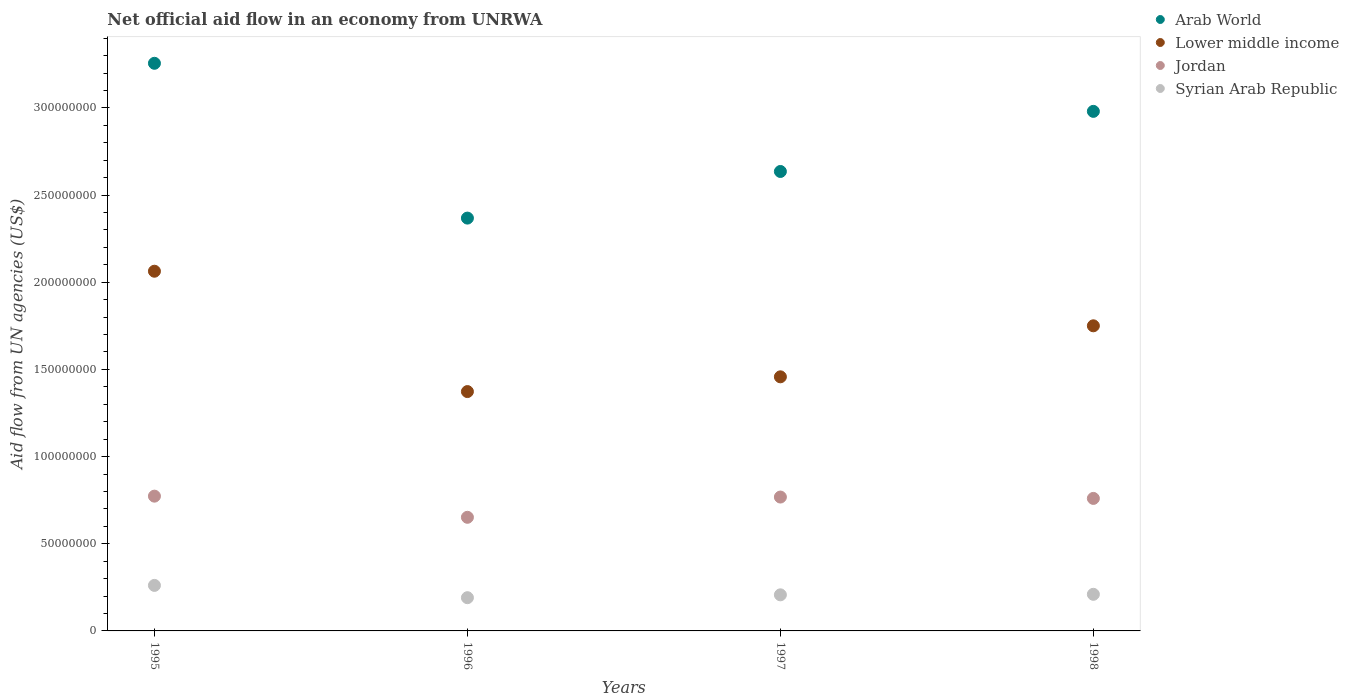How many different coloured dotlines are there?
Provide a succinct answer. 4. Is the number of dotlines equal to the number of legend labels?
Your answer should be very brief. Yes. What is the net official aid flow in Syrian Arab Republic in 1997?
Provide a succinct answer. 2.07e+07. Across all years, what is the maximum net official aid flow in Lower middle income?
Provide a short and direct response. 2.06e+08. Across all years, what is the minimum net official aid flow in Arab World?
Provide a short and direct response. 2.37e+08. In which year was the net official aid flow in Syrian Arab Republic maximum?
Make the answer very short. 1995. What is the total net official aid flow in Lower middle income in the graph?
Keep it short and to the point. 6.64e+08. What is the difference between the net official aid flow in Syrian Arab Republic in 1996 and that in 1998?
Keep it short and to the point. -1.94e+06. What is the difference between the net official aid flow in Arab World in 1995 and the net official aid flow in Jordan in 1997?
Offer a very short reply. 2.49e+08. What is the average net official aid flow in Lower middle income per year?
Make the answer very short. 1.66e+08. In the year 1995, what is the difference between the net official aid flow in Arab World and net official aid flow in Jordan?
Offer a very short reply. 2.48e+08. In how many years, is the net official aid flow in Lower middle income greater than 290000000 US$?
Your response must be concise. 0. What is the ratio of the net official aid flow in Arab World in 1996 to that in 1997?
Keep it short and to the point. 0.9. Is the net official aid flow in Lower middle income in 1996 less than that in 1998?
Provide a succinct answer. Yes. What is the difference between the highest and the second highest net official aid flow in Jordan?
Your answer should be compact. 5.20e+05. What is the difference between the highest and the lowest net official aid flow in Lower middle income?
Offer a terse response. 6.90e+07. Is it the case that in every year, the sum of the net official aid flow in Arab World and net official aid flow in Jordan  is greater than the sum of net official aid flow in Lower middle income and net official aid flow in Syrian Arab Republic?
Offer a very short reply. Yes. Does the net official aid flow in Lower middle income monotonically increase over the years?
Your answer should be very brief. No. Is the net official aid flow in Syrian Arab Republic strictly greater than the net official aid flow in Arab World over the years?
Provide a short and direct response. No. Does the graph contain grids?
Make the answer very short. No. How many legend labels are there?
Give a very brief answer. 4. What is the title of the graph?
Offer a very short reply. Net official aid flow in an economy from UNRWA. What is the label or title of the Y-axis?
Keep it short and to the point. Aid flow from UN agencies (US$). What is the Aid flow from UN agencies (US$) in Arab World in 1995?
Your response must be concise. 3.26e+08. What is the Aid flow from UN agencies (US$) of Lower middle income in 1995?
Keep it short and to the point. 2.06e+08. What is the Aid flow from UN agencies (US$) in Jordan in 1995?
Provide a succinct answer. 7.73e+07. What is the Aid flow from UN agencies (US$) of Syrian Arab Republic in 1995?
Make the answer very short. 2.61e+07. What is the Aid flow from UN agencies (US$) of Arab World in 1996?
Keep it short and to the point. 2.37e+08. What is the Aid flow from UN agencies (US$) of Lower middle income in 1996?
Provide a short and direct response. 1.37e+08. What is the Aid flow from UN agencies (US$) of Jordan in 1996?
Your answer should be very brief. 6.52e+07. What is the Aid flow from UN agencies (US$) in Syrian Arab Republic in 1996?
Offer a very short reply. 1.91e+07. What is the Aid flow from UN agencies (US$) in Arab World in 1997?
Your response must be concise. 2.64e+08. What is the Aid flow from UN agencies (US$) in Lower middle income in 1997?
Your answer should be compact. 1.46e+08. What is the Aid flow from UN agencies (US$) in Jordan in 1997?
Your answer should be compact. 7.68e+07. What is the Aid flow from UN agencies (US$) in Syrian Arab Republic in 1997?
Provide a succinct answer. 2.07e+07. What is the Aid flow from UN agencies (US$) in Arab World in 1998?
Provide a short and direct response. 2.98e+08. What is the Aid flow from UN agencies (US$) in Lower middle income in 1998?
Your answer should be very brief. 1.75e+08. What is the Aid flow from UN agencies (US$) in Jordan in 1998?
Offer a terse response. 7.60e+07. What is the Aid flow from UN agencies (US$) of Syrian Arab Republic in 1998?
Provide a succinct answer. 2.10e+07. Across all years, what is the maximum Aid flow from UN agencies (US$) in Arab World?
Your response must be concise. 3.26e+08. Across all years, what is the maximum Aid flow from UN agencies (US$) of Lower middle income?
Ensure brevity in your answer.  2.06e+08. Across all years, what is the maximum Aid flow from UN agencies (US$) in Jordan?
Provide a short and direct response. 7.73e+07. Across all years, what is the maximum Aid flow from UN agencies (US$) in Syrian Arab Republic?
Offer a very short reply. 2.61e+07. Across all years, what is the minimum Aid flow from UN agencies (US$) in Arab World?
Ensure brevity in your answer.  2.37e+08. Across all years, what is the minimum Aid flow from UN agencies (US$) in Lower middle income?
Provide a succinct answer. 1.37e+08. Across all years, what is the minimum Aid flow from UN agencies (US$) of Jordan?
Keep it short and to the point. 6.52e+07. Across all years, what is the minimum Aid flow from UN agencies (US$) of Syrian Arab Republic?
Give a very brief answer. 1.91e+07. What is the total Aid flow from UN agencies (US$) of Arab World in the graph?
Offer a terse response. 1.12e+09. What is the total Aid flow from UN agencies (US$) in Lower middle income in the graph?
Provide a short and direct response. 6.64e+08. What is the total Aid flow from UN agencies (US$) in Jordan in the graph?
Offer a very short reply. 2.95e+08. What is the total Aid flow from UN agencies (US$) in Syrian Arab Republic in the graph?
Your response must be concise. 8.69e+07. What is the difference between the Aid flow from UN agencies (US$) of Arab World in 1995 and that in 1996?
Offer a terse response. 8.88e+07. What is the difference between the Aid flow from UN agencies (US$) of Lower middle income in 1995 and that in 1996?
Ensure brevity in your answer.  6.90e+07. What is the difference between the Aid flow from UN agencies (US$) of Jordan in 1995 and that in 1996?
Make the answer very short. 1.21e+07. What is the difference between the Aid flow from UN agencies (US$) of Syrian Arab Republic in 1995 and that in 1996?
Give a very brief answer. 7.05e+06. What is the difference between the Aid flow from UN agencies (US$) in Arab World in 1995 and that in 1997?
Your answer should be compact. 6.20e+07. What is the difference between the Aid flow from UN agencies (US$) in Lower middle income in 1995 and that in 1997?
Offer a very short reply. 6.06e+07. What is the difference between the Aid flow from UN agencies (US$) of Jordan in 1995 and that in 1997?
Your answer should be very brief. 5.20e+05. What is the difference between the Aid flow from UN agencies (US$) in Syrian Arab Republic in 1995 and that in 1997?
Your answer should be very brief. 5.41e+06. What is the difference between the Aid flow from UN agencies (US$) in Arab World in 1995 and that in 1998?
Provide a short and direct response. 2.76e+07. What is the difference between the Aid flow from UN agencies (US$) in Lower middle income in 1995 and that in 1998?
Your response must be concise. 3.13e+07. What is the difference between the Aid flow from UN agencies (US$) of Jordan in 1995 and that in 1998?
Keep it short and to the point. 1.30e+06. What is the difference between the Aid flow from UN agencies (US$) in Syrian Arab Republic in 1995 and that in 1998?
Keep it short and to the point. 5.11e+06. What is the difference between the Aid flow from UN agencies (US$) in Arab World in 1996 and that in 1997?
Ensure brevity in your answer.  -2.67e+07. What is the difference between the Aid flow from UN agencies (US$) in Lower middle income in 1996 and that in 1997?
Give a very brief answer. -8.46e+06. What is the difference between the Aid flow from UN agencies (US$) in Jordan in 1996 and that in 1997?
Make the answer very short. -1.16e+07. What is the difference between the Aid flow from UN agencies (US$) in Syrian Arab Republic in 1996 and that in 1997?
Make the answer very short. -1.64e+06. What is the difference between the Aid flow from UN agencies (US$) in Arab World in 1996 and that in 1998?
Keep it short and to the point. -6.12e+07. What is the difference between the Aid flow from UN agencies (US$) of Lower middle income in 1996 and that in 1998?
Ensure brevity in your answer.  -3.77e+07. What is the difference between the Aid flow from UN agencies (US$) in Jordan in 1996 and that in 1998?
Ensure brevity in your answer.  -1.08e+07. What is the difference between the Aid flow from UN agencies (US$) in Syrian Arab Republic in 1996 and that in 1998?
Give a very brief answer. -1.94e+06. What is the difference between the Aid flow from UN agencies (US$) in Arab World in 1997 and that in 1998?
Offer a terse response. -3.45e+07. What is the difference between the Aid flow from UN agencies (US$) in Lower middle income in 1997 and that in 1998?
Your answer should be very brief. -2.93e+07. What is the difference between the Aid flow from UN agencies (US$) in Jordan in 1997 and that in 1998?
Keep it short and to the point. 7.80e+05. What is the difference between the Aid flow from UN agencies (US$) in Arab World in 1995 and the Aid flow from UN agencies (US$) in Lower middle income in 1996?
Ensure brevity in your answer.  1.88e+08. What is the difference between the Aid flow from UN agencies (US$) of Arab World in 1995 and the Aid flow from UN agencies (US$) of Jordan in 1996?
Ensure brevity in your answer.  2.60e+08. What is the difference between the Aid flow from UN agencies (US$) in Arab World in 1995 and the Aid flow from UN agencies (US$) in Syrian Arab Republic in 1996?
Your answer should be compact. 3.07e+08. What is the difference between the Aid flow from UN agencies (US$) in Lower middle income in 1995 and the Aid flow from UN agencies (US$) in Jordan in 1996?
Give a very brief answer. 1.41e+08. What is the difference between the Aid flow from UN agencies (US$) of Lower middle income in 1995 and the Aid flow from UN agencies (US$) of Syrian Arab Republic in 1996?
Your answer should be compact. 1.87e+08. What is the difference between the Aid flow from UN agencies (US$) of Jordan in 1995 and the Aid flow from UN agencies (US$) of Syrian Arab Republic in 1996?
Your response must be concise. 5.82e+07. What is the difference between the Aid flow from UN agencies (US$) in Arab World in 1995 and the Aid flow from UN agencies (US$) in Lower middle income in 1997?
Your answer should be compact. 1.80e+08. What is the difference between the Aid flow from UN agencies (US$) in Arab World in 1995 and the Aid flow from UN agencies (US$) in Jordan in 1997?
Provide a short and direct response. 2.49e+08. What is the difference between the Aid flow from UN agencies (US$) in Arab World in 1995 and the Aid flow from UN agencies (US$) in Syrian Arab Republic in 1997?
Your answer should be very brief. 3.05e+08. What is the difference between the Aid flow from UN agencies (US$) of Lower middle income in 1995 and the Aid flow from UN agencies (US$) of Jordan in 1997?
Keep it short and to the point. 1.30e+08. What is the difference between the Aid flow from UN agencies (US$) in Lower middle income in 1995 and the Aid flow from UN agencies (US$) in Syrian Arab Republic in 1997?
Make the answer very short. 1.86e+08. What is the difference between the Aid flow from UN agencies (US$) in Jordan in 1995 and the Aid flow from UN agencies (US$) in Syrian Arab Republic in 1997?
Offer a very short reply. 5.66e+07. What is the difference between the Aid flow from UN agencies (US$) of Arab World in 1995 and the Aid flow from UN agencies (US$) of Lower middle income in 1998?
Keep it short and to the point. 1.51e+08. What is the difference between the Aid flow from UN agencies (US$) in Arab World in 1995 and the Aid flow from UN agencies (US$) in Jordan in 1998?
Your response must be concise. 2.50e+08. What is the difference between the Aid flow from UN agencies (US$) of Arab World in 1995 and the Aid flow from UN agencies (US$) of Syrian Arab Republic in 1998?
Offer a very short reply. 3.05e+08. What is the difference between the Aid flow from UN agencies (US$) in Lower middle income in 1995 and the Aid flow from UN agencies (US$) in Jordan in 1998?
Offer a very short reply. 1.30e+08. What is the difference between the Aid flow from UN agencies (US$) of Lower middle income in 1995 and the Aid flow from UN agencies (US$) of Syrian Arab Republic in 1998?
Offer a very short reply. 1.85e+08. What is the difference between the Aid flow from UN agencies (US$) of Jordan in 1995 and the Aid flow from UN agencies (US$) of Syrian Arab Republic in 1998?
Provide a short and direct response. 5.63e+07. What is the difference between the Aid flow from UN agencies (US$) in Arab World in 1996 and the Aid flow from UN agencies (US$) in Lower middle income in 1997?
Keep it short and to the point. 9.10e+07. What is the difference between the Aid flow from UN agencies (US$) of Arab World in 1996 and the Aid flow from UN agencies (US$) of Jordan in 1997?
Your answer should be very brief. 1.60e+08. What is the difference between the Aid flow from UN agencies (US$) of Arab World in 1996 and the Aid flow from UN agencies (US$) of Syrian Arab Republic in 1997?
Provide a succinct answer. 2.16e+08. What is the difference between the Aid flow from UN agencies (US$) of Lower middle income in 1996 and the Aid flow from UN agencies (US$) of Jordan in 1997?
Your answer should be compact. 6.05e+07. What is the difference between the Aid flow from UN agencies (US$) of Lower middle income in 1996 and the Aid flow from UN agencies (US$) of Syrian Arab Republic in 1997?
Provide a succinct answer. 1.17e+08. What is the difference between the Aid flow from UN agencies (US$) in Jordan in 1996 and the Aid flow from UN agencies (US$) in Syrian Arab Republic in 1997?
Your answer should be compact. 4.45e+07. What is the difference between the Aid flow from UN agencies (US$) in Arab World in 1996 and the Aid flow from UN agencies (US$) in Lower middle income in 1998?
Give a very brief answer. 6.18e+07. What is the difference between the Aid flow from UN agencies (US$) of Arab World in 1996 and the Aid flow from UN agencies (US$) of Jordan in 1998?
Give a very brief answer. 1.61e+08. What is the difference between the Aid flow from UN agencies (US$) in Arab World in 1996 and the Aid flow from UN agencies (US$) in Syrian Arab Republic in 1998?
Provide a short and direct response. 2.16e+08. What is the difference between the Aid flow from UN agencies (US$) in Lower middle income in 1996 and the Aid flow from UN agencies (US$) in Jordan in 1998?
Your answer should be compact. 6.13e+07. What is the difference between the Aid flow from UN agencies (US$) of Lower middle income in 1996 and the Aid flow from UN agencies (US$) of Syrian Arab Republic in 1998?
Your answer should be very brief. 1.16e+08. What is the difference between the Aid flow from UN agencies (US$) in Jordan in 1996 and the Aid flow from UN agencies (US$) in Syrian Arab Republic in 1998?
Provide a short and direct response. 4.42e+07. What is the difference between the Aid flow from UN agencies (US$) of Arab World in 1997 and the Aid flow from UN agencies (US$) of Lower middle income in 1998?
Keep it short and to the point. 8.85e+07. What is the difference between the Aid flow from UN agencies (US$) in Arab World in 1997 and the Aid flow from UN agencies (US$) in Jordan in 1998?
Ensure brevity in your answer.  1.88e+08. What is the difference between the Aid flow from UN agencies (US$) in Arab World in 1997 and the Aid flow from UN agencies (US$) in Syrian Arab Republic in 1998?
Your answer should be very brief. 2.43e+08. What is the difference between the Aid flow from UN agencies (US$) in Lower middle income in 1997 and the Aid flow from UN agencies (US$) in Jordan in 1998?
Your answer should be very brief. 6.97e+07. What is the difference between the Aid flow from UN agencies (US$) in Lower middle income in 1997 and the Aid flow from UN agencies (US$) in Syrian Arab Republic in 1998?
Your answer should be very brief. 1.25e+08. What is the difference between the Aid flow from UN agencies (US$) in Jordan in 1997 and the Aid flow from UN agencies (US$) in Syrian Arab Republic in 1998?
Make the answer very short. 5.58e+07. What is the average Aid flow from UN agencies (US$) in Arab World per year?
Offer a very short reply. 2.81e+08. What is the average Aid flow from UN agencies (US$) in Lower middle income per year?
Your answer should be very brief. 1.66e+08. What is the average Aid flow from UN agencies (US$) of Jordan per year?
Provide a succinct answer. 7.38e+07. What is the average Aid flow from UN agencies (US$) of Syrian Arab Republic per year?
Ensure brevity in your answer.  2.17e+07. In the year 1995, what is the difference between the Aid flow from UN agencies (US$) in Arab World and Aid flow from UN agencies (US$) in Lower middle income?
Provide a succinct answer. 1.19e+08. In the year 1995, what is the difference between the Aid flow from UN agencies (US$) of Arab World and Aid flow from UN agencies (US$) of Jordan?
Ensure brevity in your answer.  2.48e+08. In the year 1995, what is the difference between the Aid flow from UN agencies (US$) of Arab World and Aid flow from UN agencies (US$) of Syrian Arab Republic?
Give a very brief answer. 2.99e+08. In the year 1995, what is the difference between the Aid flow from UN agencies (US$) in Lower middle income and Aid flow from UN agencies (US$) in Jordan?
Make the answer very short. 1.29e+08. In the year 1995, what is the difference between the Aid flow from UN agencies (US$) in Lower middle income and Aid flow from UN agencies (US$) in Syrian Arab Republic?
Your answer should be very brief. 1.80e+08. In the year 1995, what is the difference between the Aid flow from UN agencies (US$) of Jordan and Aid flow from UN agencies (US$) of Syrian Arab Republic?
Provide a short and direct response. 5.12e+07. In the year 1996, what is the difference between the Aid flow from UN agencies (US$) in Arab World and Aid flow from UN agencies (US$) in Lower middle income?
Your response must be concise. 9.95e+07. In the year 1996, what is the difference between the Aid flow from UN agencies (US$) in Arab World and Aid flow from UN agencies (US$) in Jordan?
Ensure brevity in your answer.  1.72e+08. In the year 1996, what is the difference between the Aid flow from UN agencies (US$) of Arab World and Aid flow from UN agencies (US$) of Syrian Arab Republic?
Offer a very short reply. 2.18e+08. In the year 1996, what is the difference between the Aid flow from UN agencies (US$) of Lower middle income and Aid flow from UN agencies (US$) of Jordan?
Provide a succinct answer. 7.21e+07. In the year 1996, what is the difference between the Aid flow from UN agencies (US$) of Lower middle income and Aid flow from UN agencies (US$) of Syrian Arab Republic?
Provide a short and direct response. 1.18e+08. In the year 1996, what is the difference between the Aid flow from UN agencies (US$) of Jordan and Aid flow from UN agencies (US$) of Syrian Arab Republic?
Ensure brevity in your answer.  4.61e+07. In the year 1997, what is the difference between the Aid flow from UN agencies (US$) of Arab World and Aid flow from UN agencies (US$) of Lower middle income?
Provide a succinct answer. 1.18e+08. In the year 1997, what is the difference between the Aid flow from UN agencies (US$) in Arab World and Aid flow from UN agencies (US$) in Jordan?
Provide a short and direct response. 1.87e+08. In the year 1997, what is the difference between the Aid flow from UN agencies (US$) in Arab World and Aid flow from UN agencies (US$) in Syrian Arab Republic?
Give a very brief answer. 2.43e+08. In the year 1997, what is the difference between the Aid flow from UN agencies (US$) in Lower middle income and Aid flow from UN agencies (US$) in Jordan?
Offer a terse response. 6.90e+07. In the year 1997, what is the difference between the Aid flow from UN agencies (US$) in Lower middle income and Aid flow from UN agencies (US$) in Syrian Arab Republic?
Your response must be concise. 1.25e+08. In the year 1997, what is the difference between the Aid flow from UN agencies (US$) in Jordan and Aid flow from UN agencies (US$) in Syrian Arab Republic?
Provide a short and direct response. 5.61e+07. In the year 1998, what is the difference between the Aid flow from UN agencies (US$) of Arab World and Aid flow from UN agencies (US$) of Lower middle income?
Provide a short and direct response. 1.23e+08. In the year 1998, what is the difference between the Aid flow from UN agencies (US$) in Arab World and Aid flow from UN agencies (US$) in Jordan?
Provide a succinct answer. 2.22e+08. In the year 1998, what is the difference between the Aid flow from UN agencies (US$) in Arab World and Aid flow from UN agencies (US$) in Syrian Arab Republic?
Provide a succinct answer. 2.77e+08. In the year 1998, what is the difference between the Aid flow from UN agencies (US$) of Lower middle income and Aid flow from UN agencies (US$) of Jordan?
Keep it short and to the point. 9.90e+07. In the year 1998, what is the difference between the Aid flow from UN agencies (US$) in Lower middle income and Aid flow from UN agencies (US$) in Syrian Arab Republic?
Give a very brief answer. 1.54e+08. In the year 1998, what is the difference between the Aid flow from UN agencies (US$) in Jordan and Aid flow from UN agencies (US$) in Syrian Arab Republic?
Ensure brevity in your answer.  5.50e+07. What is the ratio of the Aid flow from UN agencies (US$) of Arab World in 1995 to that in 1996?
Offer a terse response. 1.38. What is the ratio of the Aid flow from UN agencies (US$) of Lower middle income in 1995 to that in 1996?
Give a very brief answer. 1.5. What is the ratio of the Aid flow from UN agencies (US$) in Jordan in 1995 to that in 1996?
Ensure brevity in your answer.  1.19. What is the ratio of the Aid flow from UN agencies (US$) in Syrian Arab Republic in 1995 to that in 1996?
Your answer should be compact. 1.37. What is the ratio of the Aid flow from UN agencies (US$) of Arab World in 1995 to that in 1997?
Give a very brief answer. 1.24. What is the ratio of the Aid flow from UN agencies (US$) of Lower middle income in 1995 to that in 1997?
Make the answer very short. 1.42. What is the ratio of the Aid flow from UN agencies (US$) in Jordan in 1995 to that in 1997?
Your answer should be compact. 1.01. What is the ratio of the Aid flow from UN agencies (US$) in Syrian Arab Republic in 1995 to that in 1997?
Your answer should be compact. 1.26. What is the ratio of the Aid flow from UN agencies (US$) in Arab World in 1995 to that in 1998?
Your answer should be compact. 1.09. What is the ratio of the Aid flow from UN agencies (US$) in Lower middle income in 1995 to that in 1998?
Provide a short and direct response. 1.18. What is the ratio of the Aid flow from UN agencies (US$) in Jordan in 1995 to that in 1998?
Provide a succinct answer. 1.02. What is the ratio of the Aid flow from UN agencies (US$) of Syrian Arab Republic in 1995 to that in 1998?
Provide a succinct answer. 1.24. What is the ratio of the Aid flow from UN agencies (US$) in Arab World in 1996 to that in 1997?
Your answer should be compact. 0.9. What is the ratio of the Aid flow from UN agencies (US$) in Lower middle income in 1996 to that in 1997?
Keep it short and to the point. 0.94. What is the ratio of the Aid flow from UN agencies (US$) of Jordan in 1996 to that in 1997?
Your answer should be compact. 0.85. What is the ratio of the Aid flow from UN agencies (US$) in Syrian Arab Republic in 1996 to that in 1997?
Give a very brief answer. 0.92. What is the ratio of the Aid flow from UN agencies (US$) of Arab World in 1996 to that in 1998?
Provide a short and direct response. 0.79. What is the ratio of the Aid flow from UN agencies (US$) in Lower middle income in 1996 to that in 1998?
Offer a very short reply. 0.78. What is the ratio of the Aid flow from UN agencies (US$) of Jordan in 1996 to that in 1998?
Offer a terse response. 0.86. What is the ratio of the Aid flow from UN agencies (US$) of Syrian Arab Republic in 1996 to that in 1998?
Provide a succinct answer. 0.91. What is the ratio of the Aid flow from UN agencies (US$) of Arab World in 1997 to that in 1998?
Provide a succinct answer. 0.88. What is the ratio of the Aid flow from UN agencies (US$) in Lower middle income in 1997 to that in 1998?
Your answer should be compact. 0.83. What is the ratio of the Aid flow from UN agencies (US$) in Jordan in 1997 to that in 1998?
Your answer should be compact. 1.01. What is the ratio of the Aid flow from UN agencies (US$) of Syrian Arab Republic in 1997 to that in 1998?
Your answer should be very brief. 0.99. What is the difference between the highest and the second highest Aid flow from UN agencies (US$) of Arab World?
Keep it short and to the point. 2.76e+07. What is the difference between the highest and the second highest Aid flow from UN agencies (US$) in Lower middle income?
Ensure brevity in your answer.  3.13e+07. What is the difference between the highest and the second highest Aid flow from UN agencies (US$) in Jordan?
Keep it short and to the point. 5.20e+05. What is the difference between the highest and the second highest Aid flow from UN agencies (US$) in Syrian Arab Republic?
Your response must be concise. 5.11e+06. What is the difference between the highest and the lowest Aid flow from UN agencies (US$) in Arab World?
Your response must be concise. 8.88e+07. What is the difference between the highest and the lowest Aid flow from UN agencies (US$) in Lower middle income?
Give a very brief answer. 6.90e+07. What is the difference between the highest and the lowest Aid flow from UN agencies (US$) in Jordan?
Make the answer very short. 1.21e+07. What is the difference between the highest and the lowest Aid flow from UN agencies (US$) of Syrian Arab Republic?
Offer a very short reply. 7.05e+06. 